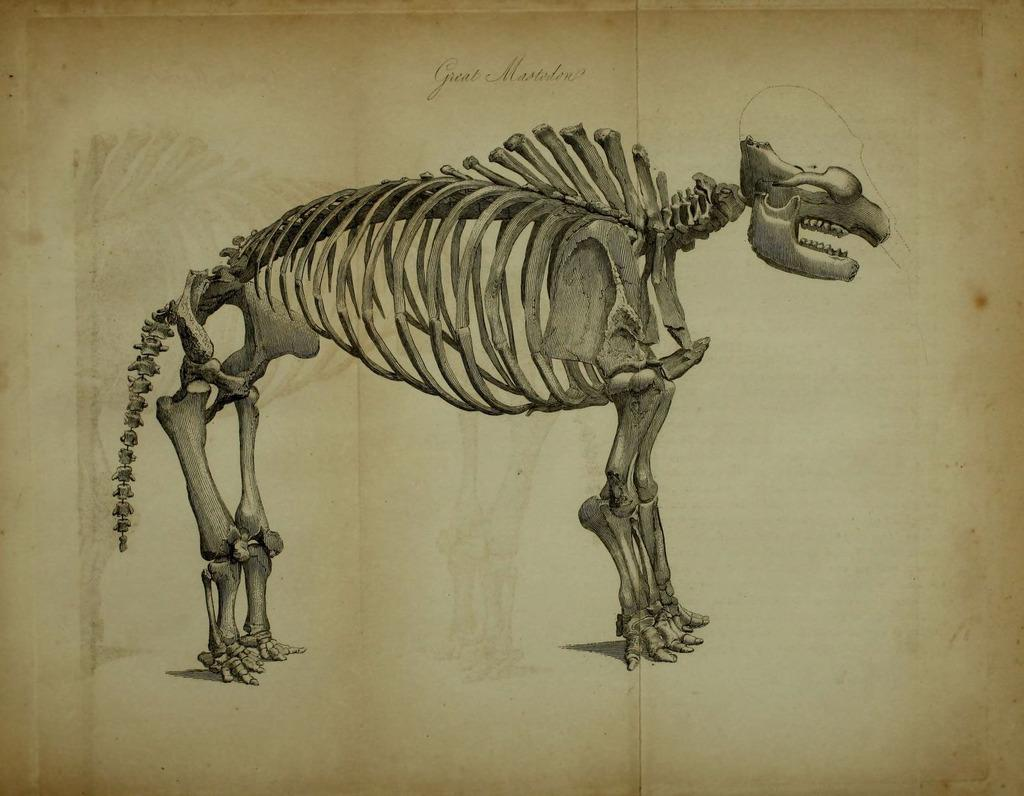What is depicted on the paper in the image? The paper contains a drawing or image of an animal skeleton. How many goats can be seen climbing the trees on the slope in the image? There are no goats, trees, or slopes present in the image; it only contains a paper with a drawing or image of an animal skeleton. 